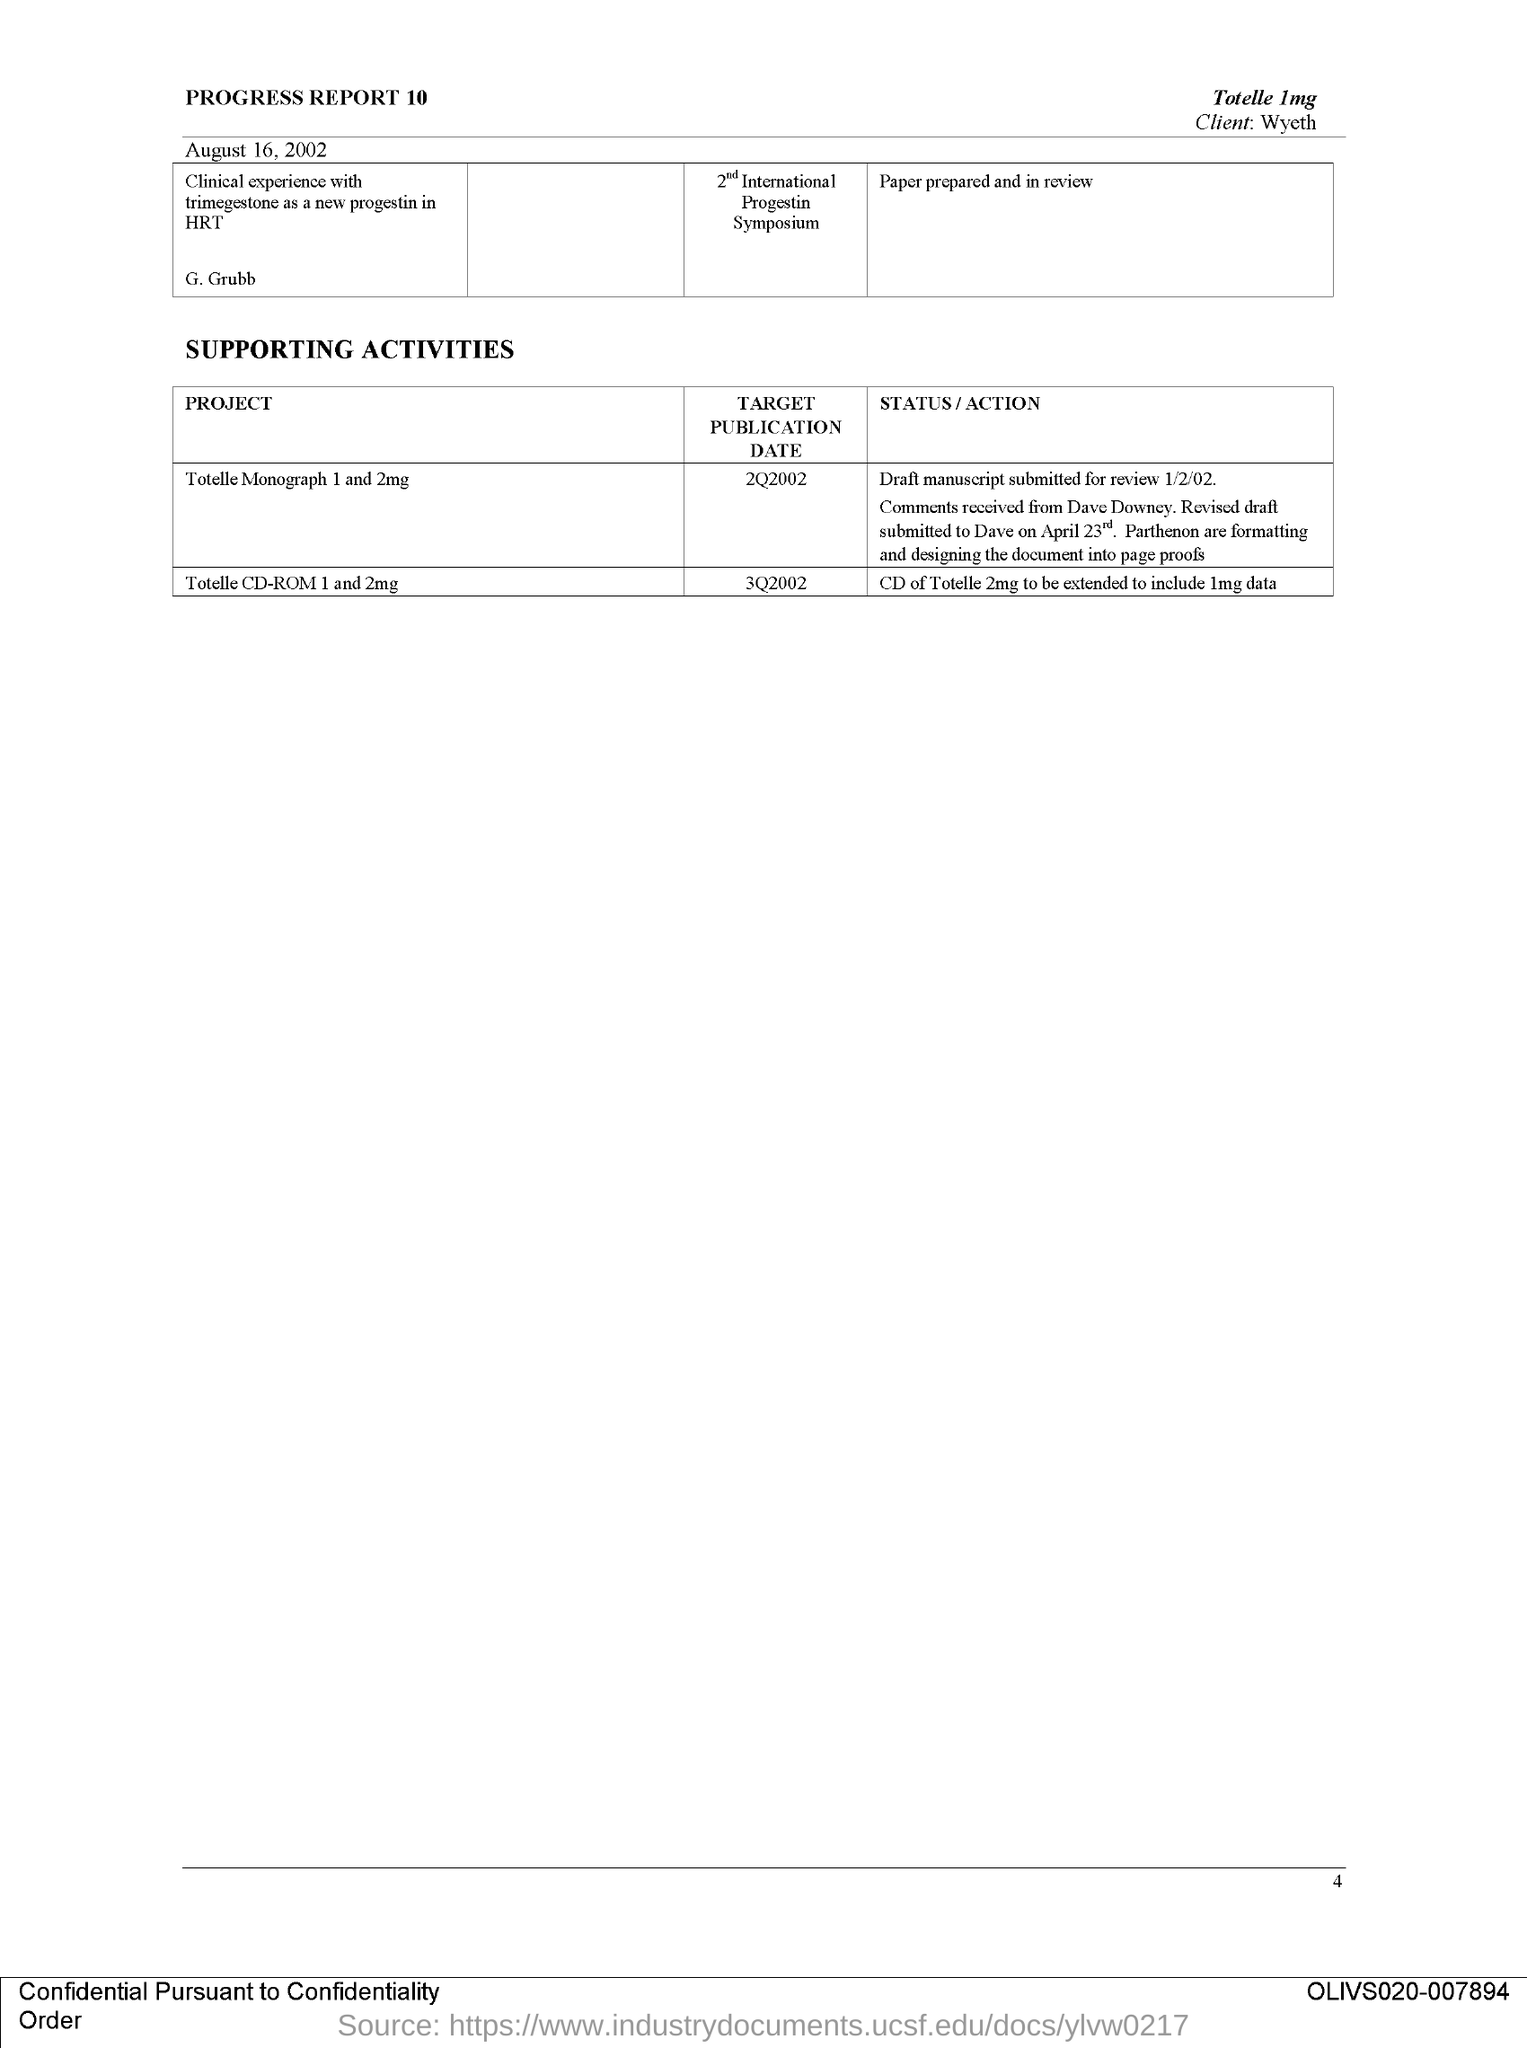Give some essential details in this illustration. The project that has the target publication date of 3Q2002 is both "Totalle CD-ROM 1" and "Totelle 2mg.. The client mentioned in the document is Wyeth. The target publication date for the project "Totelle Monograph 1 and 2mg" is the second quarter of 2002. The project "Total CD-ROM 1 and 2mg" involves expanding the CD-ROM of Total 2mg to include data from Total 1mg. The document mentions page 4. 